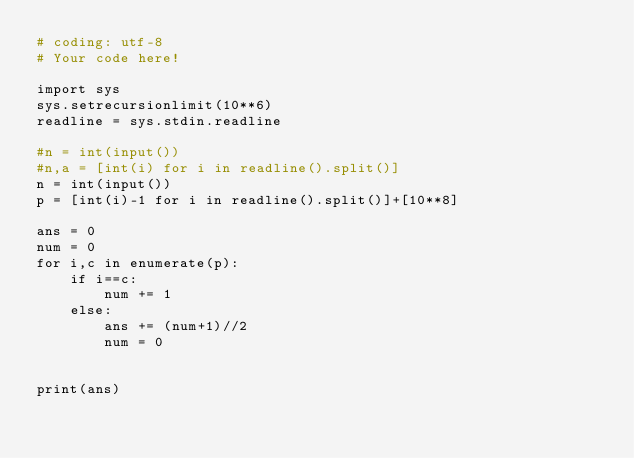Convert code to text. <code><loc_0><loc_0><loc_500><loc_500><_Python_># coding: utf-8
# Your code here!

import sys
sys.setrecursionlimit(10**6)
readline = sys.stdin.readline

#n = int(input())
#n,a = [int(i) for i in readline().split()]
n = int(input())
p = [int(i)-1 for i in readline().split()]+[10**8]

ans = 0
num = 0
for i,c in enumerate(p):
    if i==c:
        num += 1
    else:
        ans += (num+1)//2
        num = 0
    

print(ans)
</code> 